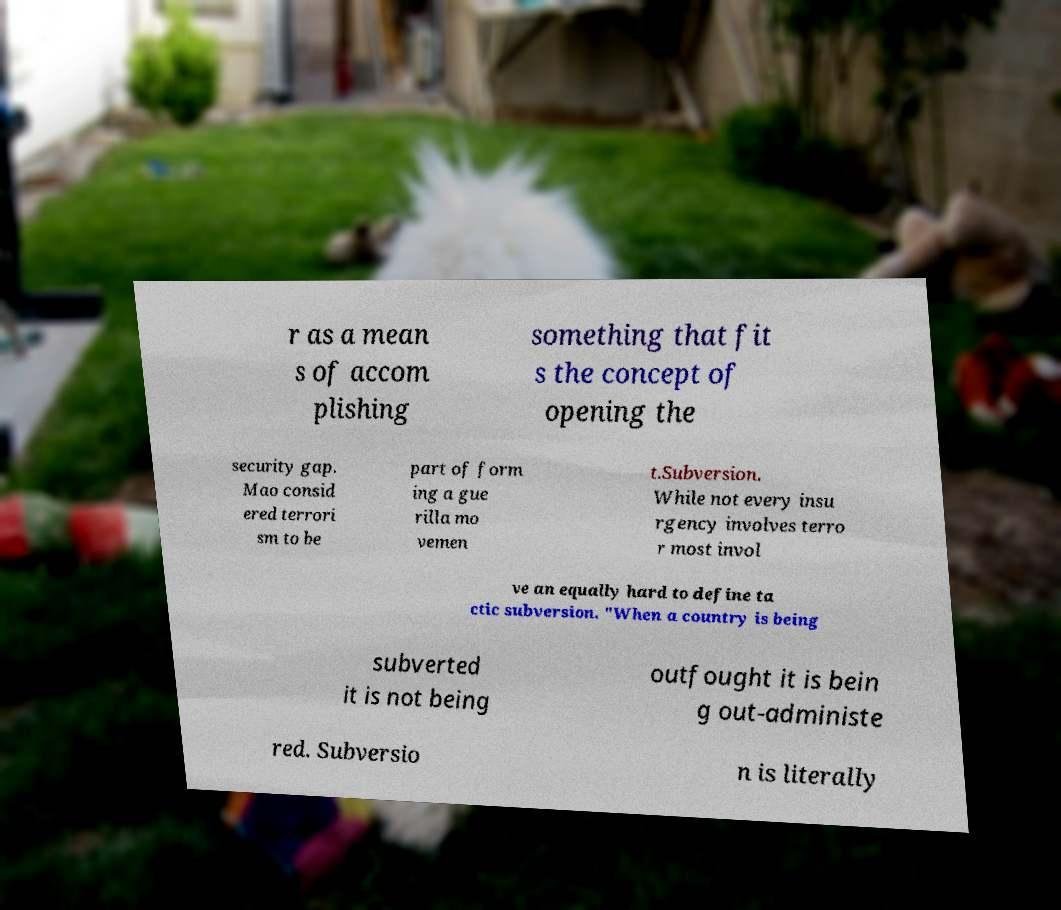Can you read and provide the text displayed in the image?This photo seems to have some interesting text. Can you extract and type it out for me? r as a mean s of accom plishing something that fit s the concept of opening the security gap. Mao consid ered terrori sm to be part of form ing a gue rilla mo vemen t.Subversion. While not every insu rgency involves terro r most invol ve an equally hard to define ta ctic subversion. "When a country is being subverted it is not being outfought it is bein g out-administe red. Subversio n is literally 